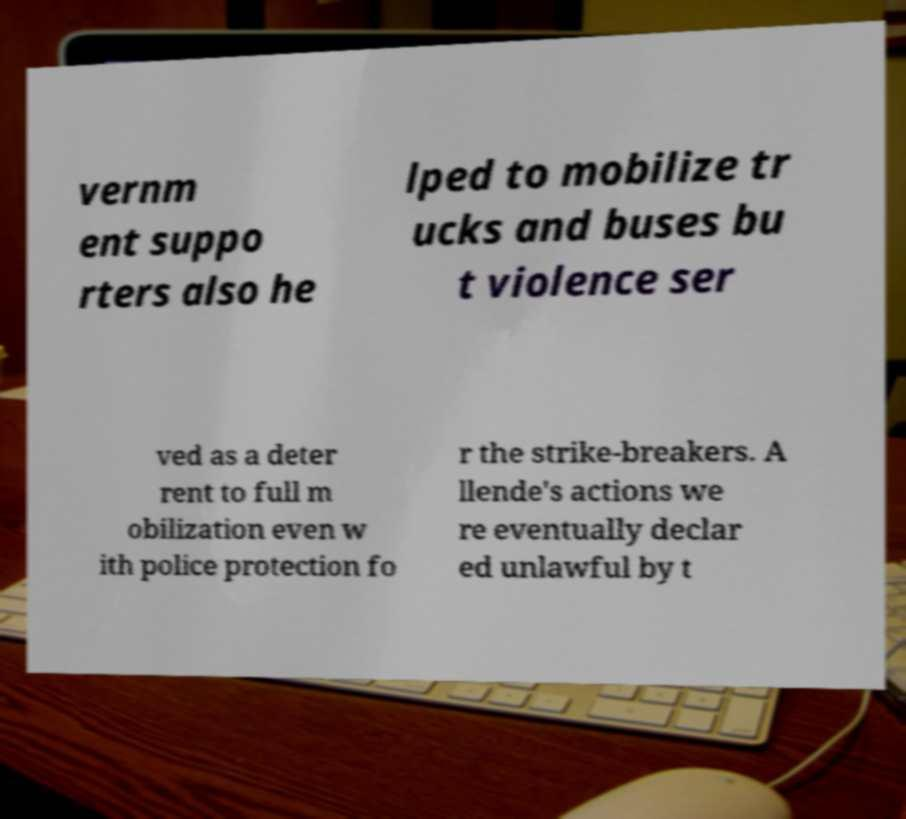Please read and relay the text visible in this image. What does it say? vernm ent suppo rters also he lped to mobilize tr ucks and buses bu t violence ser ved as a deter rent to full m obilization even w ith police protection fo r the strike-breakers. A llende's actions we re eventually declar ed unlawful by t 